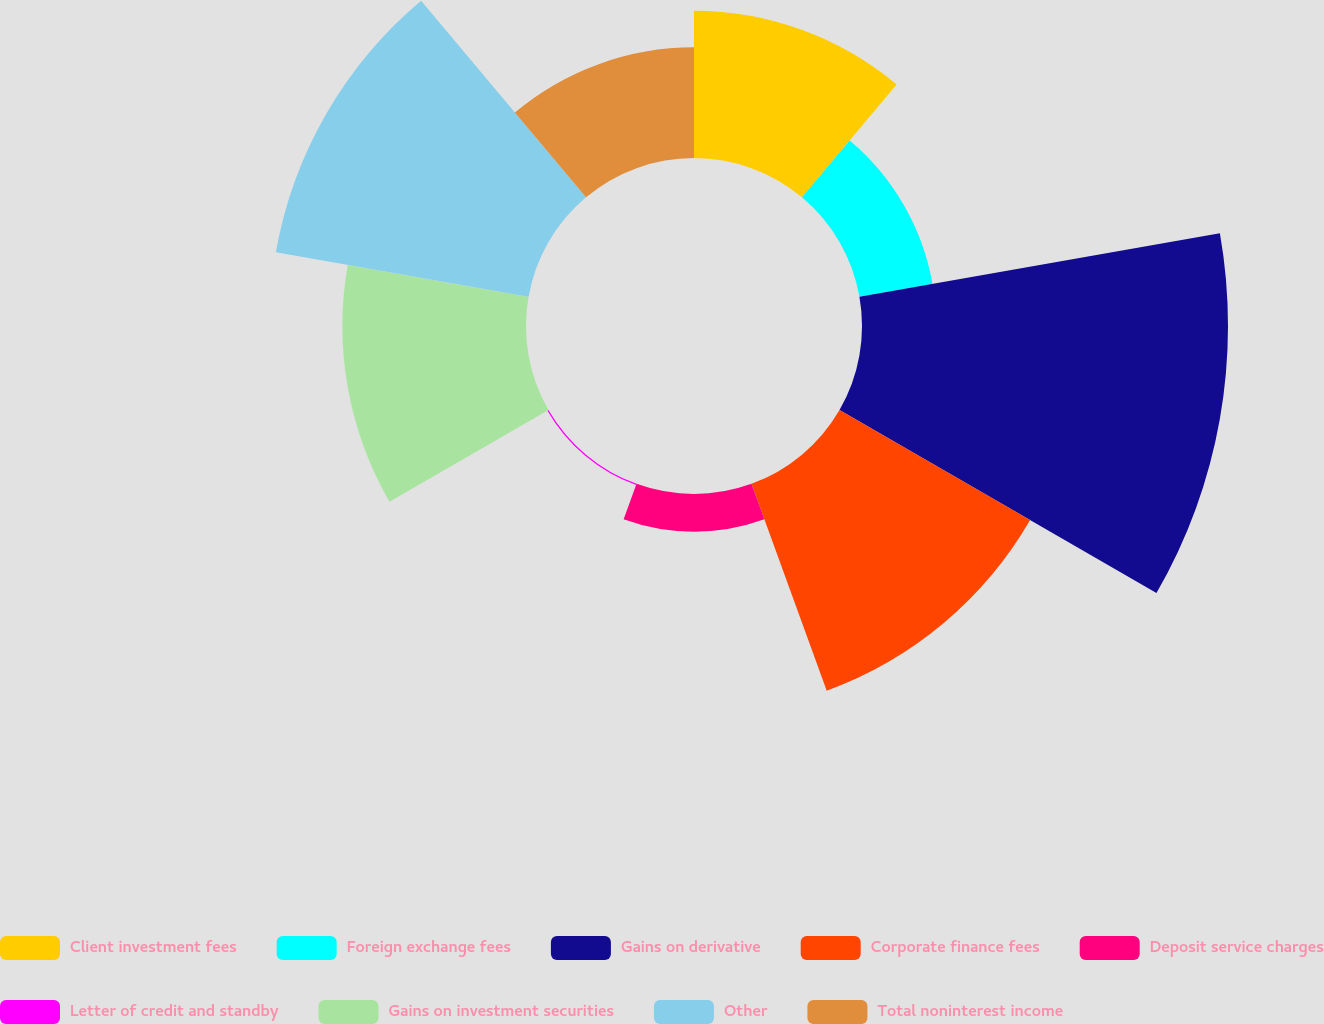Convert chart. <chart><loc_0><loc_0><loc_500><loc_500><pie_chart><fcel>Client investment fees<fcel>Foreign exchange fees<fcel>Gains on derivative<fcel>Corporate finance fees<fcel>Deposit service charges<fcel>Letter of credit and standby<fcel>Gains on investment securities<fcel>Other<fcel>Total noninterest income<nl><fcel>10.53%<fcel>5.31%<fcel>26.19%<fcel>15.75%<fcel>2.7%<fcel>0.09%<fcel>13.14%<fcel>18.36%<fcel>7.92%<nl></chart> 